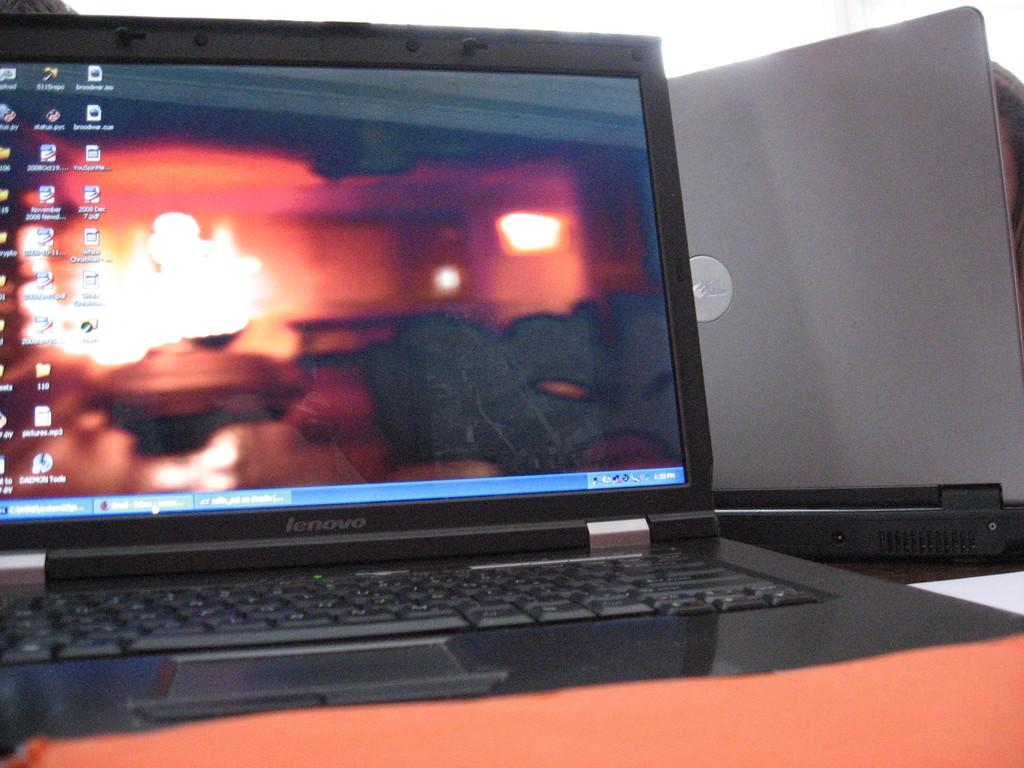Provide a one-sentence caption for the provided image. The black laptop on the table reads lenovo. 